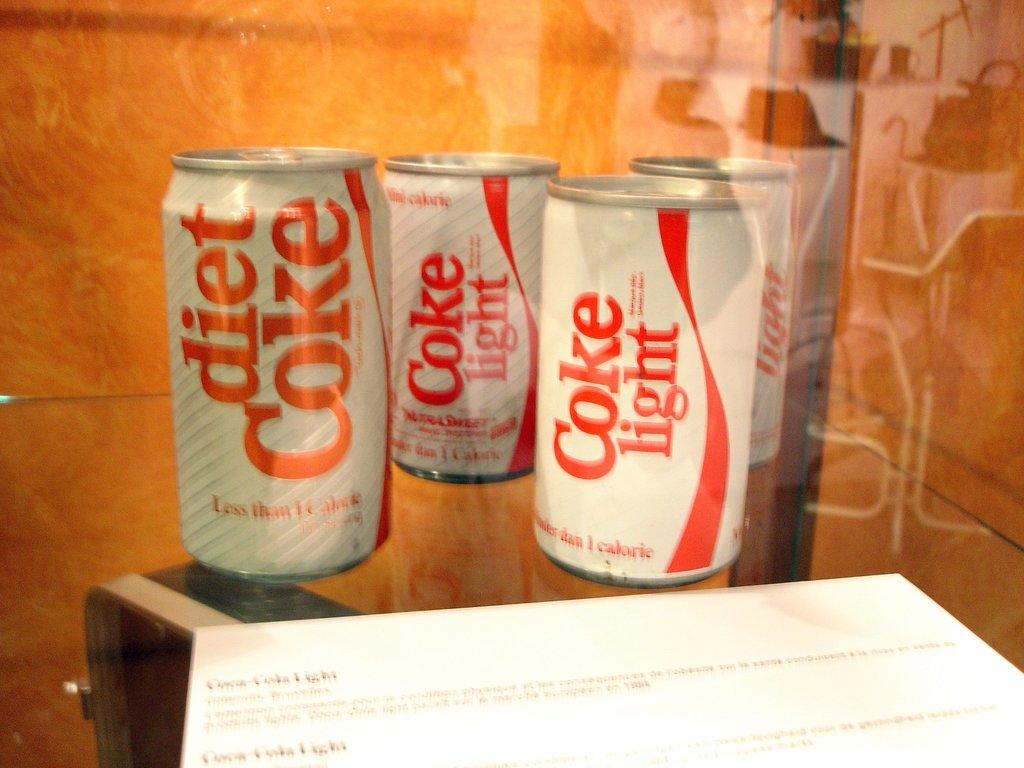<image>
Write a terse but informative summary of the picture. Several cans of Coke Light are standing near each other in front of a white paper. 